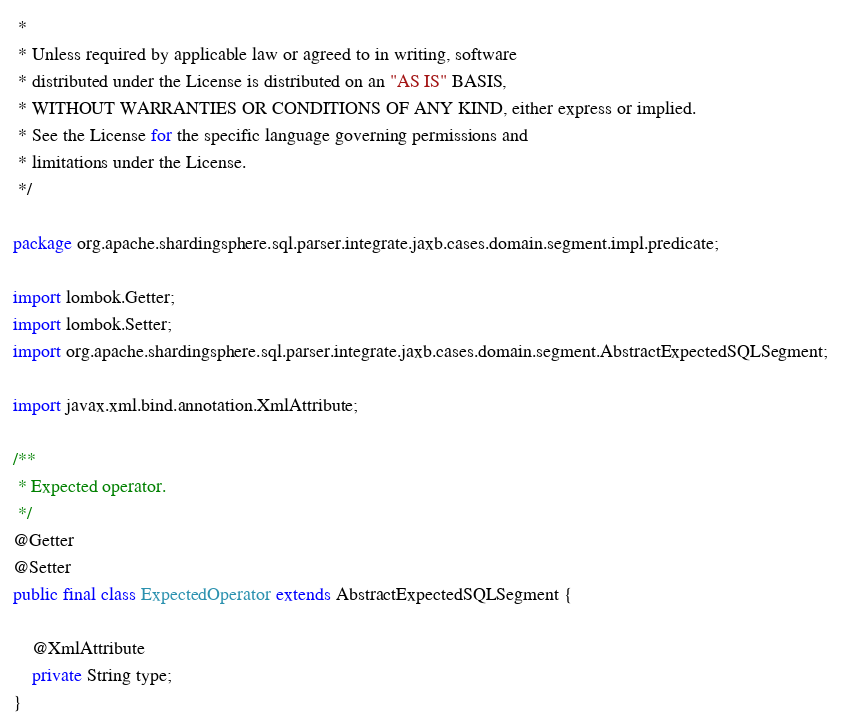<code> <loc_0><loc_0><loc_500><loc_500><_Java_> *
 * Unless required by applicable law or agreed to in writing, software
 * distributed under the License is distributed on an "AS IS" BASIS,
 * WITHOUT WARRANTIES OR CONDITIONS OF ANY KIND, either express or implied.
 * See the License for the specific language governing permissions and
 * limitations under the License.
 */

package org.apache.shardingsphere.sql.parser.integrate.jaxb.cases.domain.segment.impl.predicate;

import lombok.Getter;
import lombok.Setter;
import org.apache.shardingsphere.sql.parser.integrate.jaxb.cases.domain.segment.AbstractExpectedSQLSegment;

import javax.xml.bind.annotation.XmlAttribute;

/**
 * Expected operator.
 */
@Getter
@Setter
public final class ExpectedOperator extends AbstractExpectedSQLSegment {
    
    @XmlAttribute
    private String type;
}
</code> 